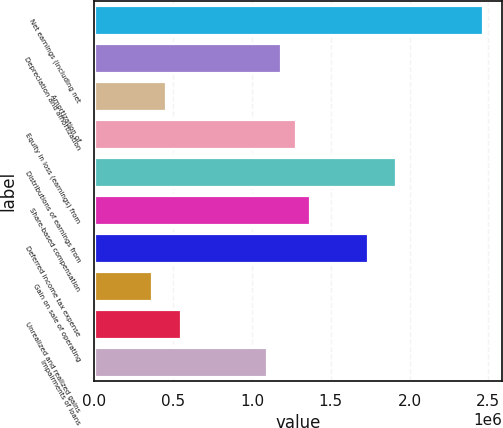Convert chart. <chart><loc_0><loc_0><loc_500><loc_500><bar_chart><fcel>Net earnings (including net<fcel>Depreciation and amortization<fcel>Amortization of<fcel>Equity in loss (earnings) from<fcel>Distributions of earnings from<fcel>Share-based compensation<fcel>Deferred income tax expense<fcel>Gain on sale of operating<fcel>Unrealized and realized gains<fcel>Impairments of loans<nl><fcel>2.46411e+06<fcel>1.1868e+06<fcel>456908<fcel>1.27804e+06<fcel>1.91669e+06<fcel>1.36927e+06<fcel>1.73422e+06<fcel>365671<fcel>548145<fcel>1.09556e+06<nl></chart> 